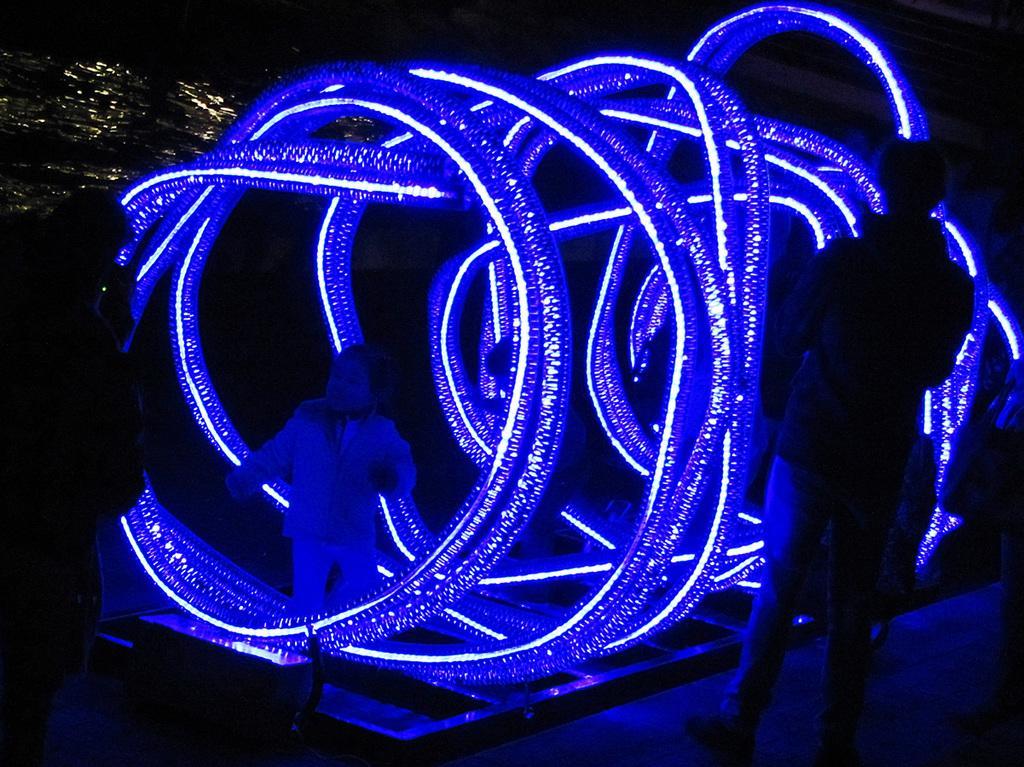Can you describe this image briefly? In this picture there are people and we can see decorative lights. In the background of the image it is dark and we can see water. 